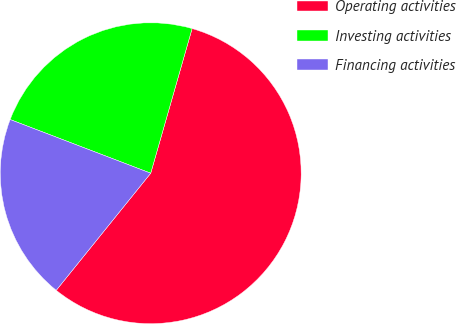<chart> <loc_0><loc_0><loc_500><loc_500><pie_chart><fcel>Operating activities<fcel>Investing activities<fcel>Financing activities<nl><fcel>56.37%<fcel>23.63%<fcel>20.0%<nl></chart> 